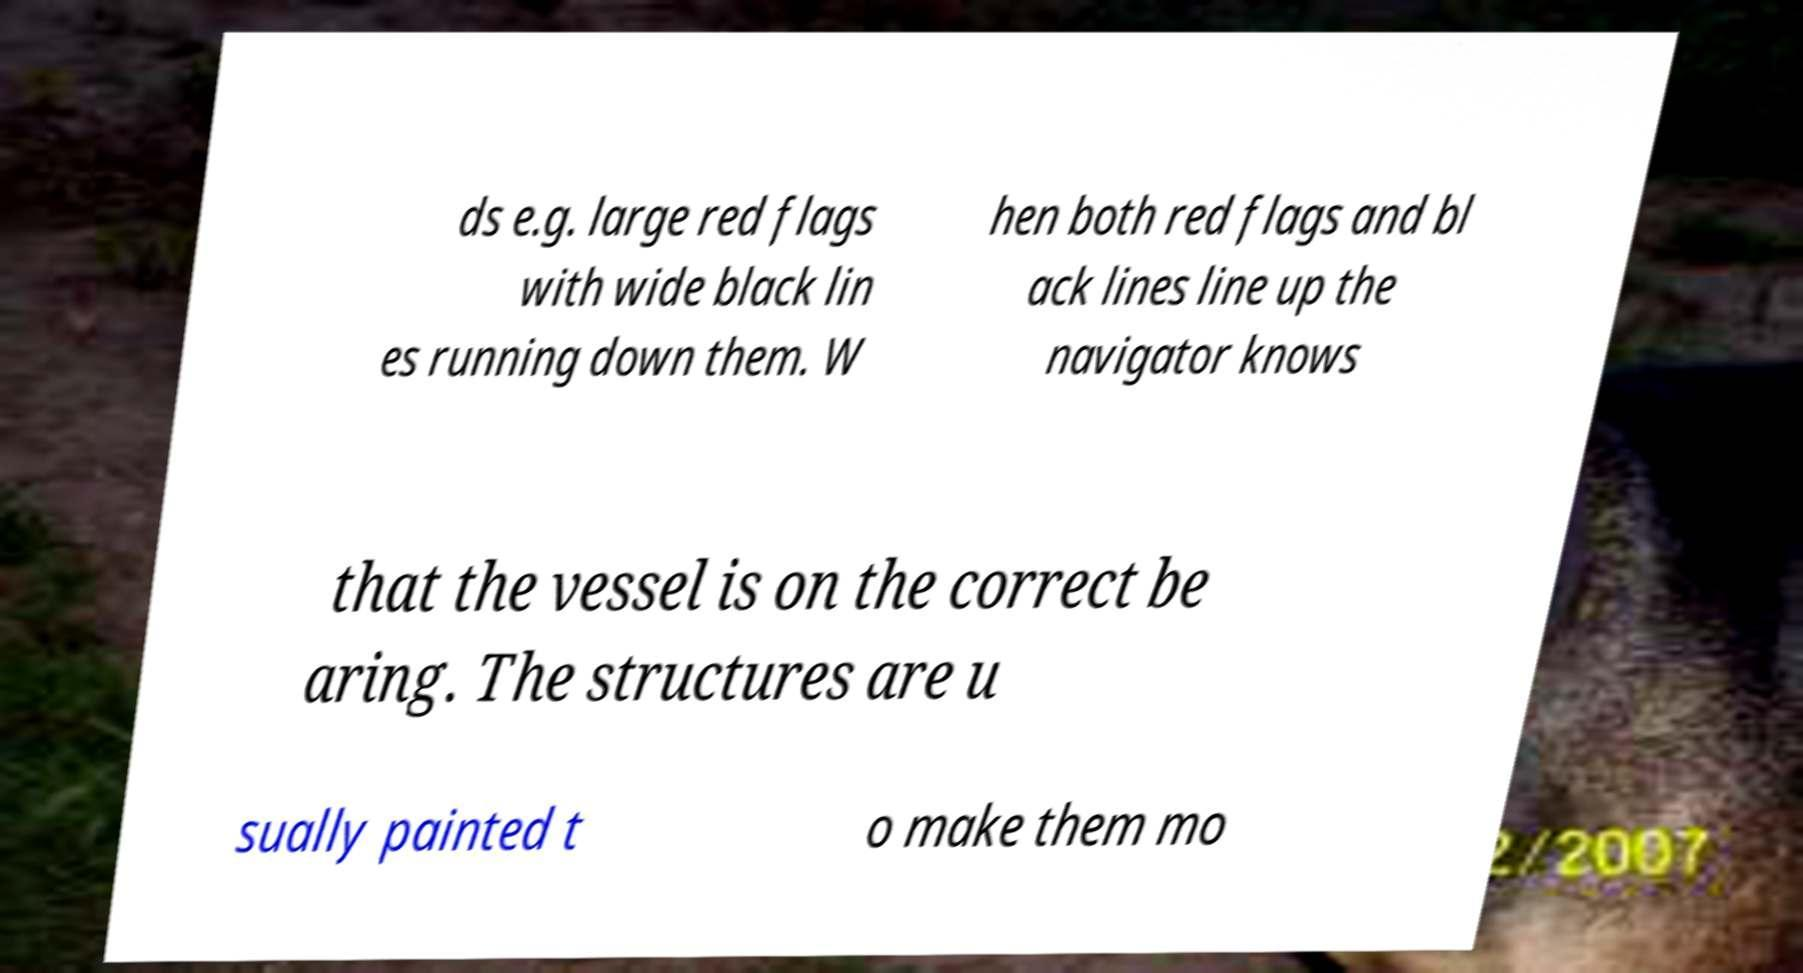Can you read and provide the text displayed in the image?This photo seems to have some interesting text. Can you extract and type it out for me? ds e.g. large red flags with wide black lin es running down them. W hen both red flags and bl ack lines line up the navigator knows that the vessel is on the correct be aring. The structures are u sually painted t o make them mo 